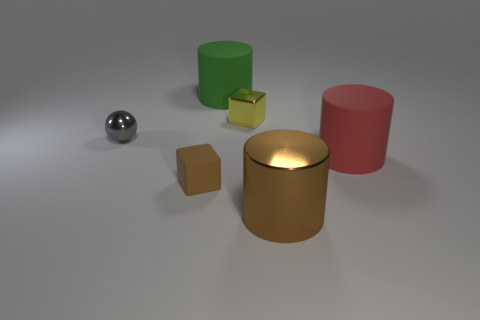Subtract all big brown shiny cylinders. How many cylinders are left? 2 Add 4 big yellow cubes. How many objects exist? 10 Subtract all spheres. How many objects are left? 5 Subtract all red cylinders. Subtract all cyan blocks. How many cylinders are left? 2 Subtract all red metal cylinders. Subtract all yellow blocks. How many objects are left? 5 Add 4 brown rubber objects. How many brown rubber objects are left? 5 Add 1 balls. How many balls exist? 2 Subtract 0 green blocks. How many objects are left? 6 